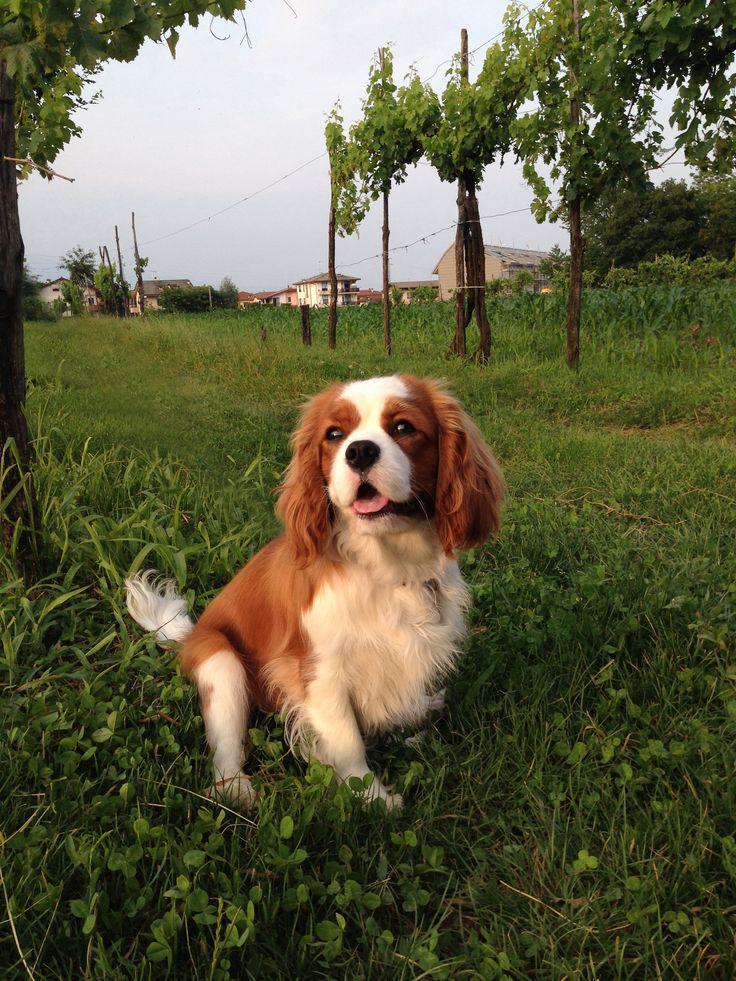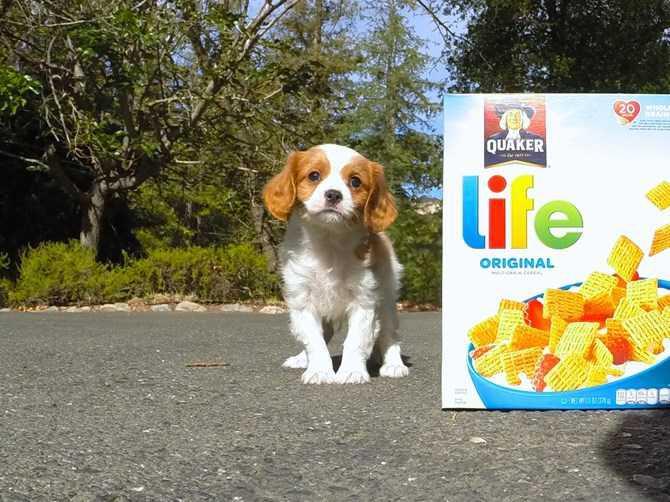The first image is the image on the left, the second image is the image on the right. For the images displayed, is the sentence "At least one of the dogs is not standing on grass." factually correct? Answer yes or no. Yes. The first image is the image on the left, the second image is the image on the right. Examine the images to the left and right. Is the description "There are more spaniels with brown ears than spaniels with black ears." accurate? Answer yes or no. Yes. 